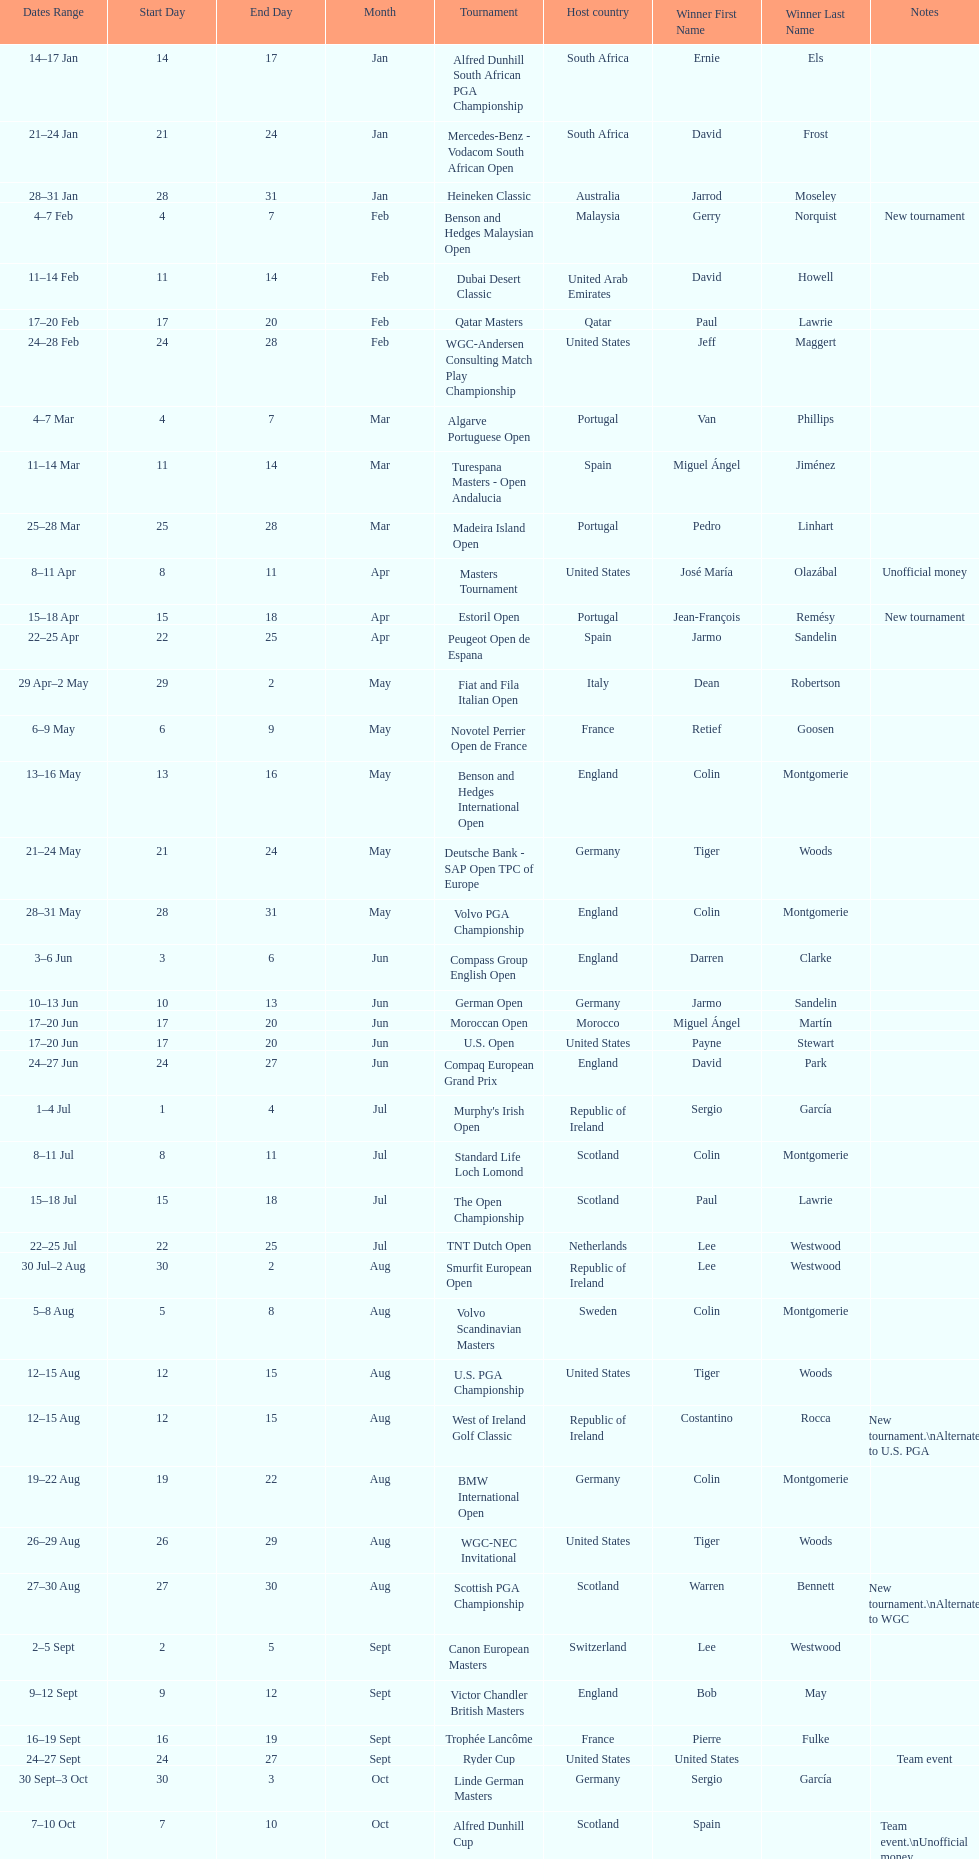Would you mind parsing the complete table? {'header': ['Dates Range', 'Start Day', 'End Day', 'Month', 'Tournament', 'Host country', 'Winner First Name', 'Winner Last Name', 'Notes'], 'rows': [['14–17\xa0Jan', '14', '17', 'Jan', 'Alfred Dunhill South African PGA Championship', 'South Africa', 'Ernie', 'Els', ''], ['21–24\xa0Jan', '21', '24', 'Jan', 'Mercedes-Benz - Vodacom South African Open', 'South Africa', 'David', 'Frost', ''], ['28–31\xa0Jan', '28', '31', 'Jan', 'Heineken Classic', 'Australia', 'Jarrod', 'Moseley', ''], ['4–7\xa0Feb', '4', '7', 'Feb', 'Benson and Hedges Malaysian Open', 'Malaysia', 'Gerry', 'Norquist', 'New tournament'], ['11–14\xa0Feb', '11', '14', 'Feb', 'Dubai Desert Classic', 'United Arab Emirates', 'David', 'Howell', ''], ['17–20\xa0Feb', '17', '20', 'Feb', 'Qatar Masters', 'Qatar', 'Paul', 'Lawrie', ''], ['24–28\xa0Feb', '24', '28', 'Feb', 'WGC-Andersen Consulting Match Play Championship', 'United States', 'Jeff', 'Maggert', ''], ['4–7\xa0Mar', '4', '7', 'Mar', 'Algarve Portuguese Open', 'Portugal', 'Van', 'Phillips', ''], ['11–14\xa0Mar', '11', '14', 'Mar', 'Turespana Masters - Open Andalucia', 'Spain', 'Miguel Ángel', 'Jiménez', ''], ['25–28\xa0Mar', '25', '28', 'Mar', 'Madeira Island Open', 'Portugal', 'Pedro', 'Linhart', ''], ['8–11\xa0Apr', '8', '11', 'Apr', 'Masters Tournament', 'United States', 'José María', 'Olazábal', 'Unofficial money'], ['15–18\xa0Apr', '15', '18', 'Apr', 'Estoril Open', 'Portugal', 'Jean-François', 'Remésy', 'New tournament'], ['22–25\xa0Apr', '22', '25', 'Apr', 'Peugeot Open de Espana', 'Spain', 'Jarmo', 'Sandelin', ''], ['29\xa0Apr–2\xa0May', '29', '2', 'May', 'Fiat and Fila Italian Open', 'Italy', 'Dean', 'Robertson', ''], ['6–9\xa0May', '6', '9', 'May', 'Novotel Perrier Open de France', 'France', 'Retief', 'Goosen', ''], ['13–16\xa0May', '13', '16', 'May', 'Benson and Hedges International Open', 'England', 'Colin', 'Montgomerie', ''], ['21–24\xa0May', '21', '24', 'May', 'Deutsche Bank - SAP Open TPC of Europe', 'Germany', 'Tiger', 'Woods', ''], ['28–31\xa0May', '28', '31', 'May', 'Volvo PGA Championship', 'England', 'Colin', 'Montgomerie', ''], ['3–6\xa0Jun', '3', '6', 'Jun', 'Compass Group English Open', 'England', 'Darren', 'Clarke', ''], ['10–13\xa0Jun', '10', '13', 'Jun', 'German Open', 'Germany', 'Jarmo', 'Sandelin', ''], ['17–20\xa0Jun', '17', '20', 'Jun', 'Moroccan Open', 'Morocco', 'Miguel Ángel', 'Martín', ''], ['17–20\xa0Jun', '17', '20', 'Jun', 'U.S. Open', 'United States', 'Payne', 'Stewart', ''], ['24–27\xa0Jun', '24', '27', 'Jun', 'Compaq European Grand Prix', 'England', 'David', 'Park', ''], ['1–4\xa0Jul', '1', '4', 'Jul', "Murphy's Irish Open", 'Republic of Ireland', 'Sergio', 'García', ''], ['8–11\xa0Jul', '8', '11', 'Jul', 'Standard Life Loch Lomond', 'Scotland', 'Colin', 'Montgomerie', ''], ['15–18\xa0Jul', '15', '18', 'Jul', 'The Open Championship', 'Scotland', 'Paul', 'Lawrie', ''], ['22–25\xa0Jul', '22', '25', 'Jul', 'TNT Dutch Open', 'Netherlands', 'Lee', 'Westwood', ''], ['30\xa0Jul–2\xa0Aug', '30', '2', 'Aug', 'Smurfit European Open', 'Republic of Ireland', 'Lee', 'Westwood', ''], ['5–8\xa0Aug', '5', '8', 'Aug', 'Volvo Scandinavian Masters', 'Sweden', 'Colin', 'Montgomerie', ''], ['12–15\xa0Aug', '12', '15', 'Aug', 'U.S. PGA Championship', 'United States', 'Tiger', 'Woods', ''], ['12–15\xa0Aug', '12', '15', 'Aug', 'West of Ireland Golf Classic', 'Republic of Ireland', 'Costantino', 'Rocca', 'New tournament.\\nAlternate to U.S. PGA'], ['19–22\xa0Aug', '19', '22', 'Aug', 'BMW International Open', 'Germany', 'Colin', 'Montgomerie', ''], ['26–29\xa0Aug', '26', '29', 'Aug', 'WGC-NEC Invitational', 'United States', 'Tiger', 'Woods', ''], ['27–30\xa0Aug', '27', '30', 'Aug', 'Scottish PGA Championship', 'Scotland', 'Warren', 'Bennett', 'New tournament.\\nAlternate to WGC'], ['2–5\xa0Sept', '2', '5', 'Sept', 'Canon European Masters', 'Switzerland', 'Lee', 'Westwood', ''], ['9–12\xa0Sept', '9', '12', 'Sept', 'Victor Chandler British Masters', 'England', 'Bob', 'May', ''], ['16–19\xa0Sept', '16', '19', 'Sept', 'Trophée Lancôme', 'France', 'Pierre', 'Fulke', ''], ['24–27\xa0Sept', '24', '27', 'Sept', 'Ryder Cup', 'United States', 'United States', '', 'Team event'], ['30\xa0Sept–3\xa0Oct', '30', '3', 'Oct', 'Linde German Masters', 'Germany', 'Sergio', 'García', ''], ['7–10\xa0Oct', '7', '10', 'Oct', 'Alfred Dunhill Cup', 'Scotland', 'Spain', '', 'Team event.\\nUnofficial money'], ['14–17\xa0Oct', '14', '17', 'Oct', 'Cisco World Match Play Championship', 'England', 'Colin', 'Montgomerie', 'Unofficial money'], ['14–17\xa0Oct', '14', '17', 'Oct', 'Sarazen World Open', 'Spain', 'Thomas', 'Bjørn', 'New tournament'], ['21–24\xa0Oct', '21', '24', 'Oct', 'Belgacom Open', 'Belgium', 'Robert', 'Karlsson', ''], ['28–31\xa0Oct', '28', '31', 'Oct', 'Volvo Masters', 'Spain', 'Miguel Ángel', 'Jiménez', ''], ['4–7\xa0Nov', '4', '7', 'Nov', 'WGC-American Express Championship', 'Spain', 'Tiger', 'Woods', ''], ['18–21\xa0Nov', '18', '21', 'Nov', 'World Cup of Golf', 'Malaysia', 'United States', '', 'Team event.\\nUnofficial money']]} Which tournament was later, volvo pga or algarve portuguese open? Volvo PGA. 